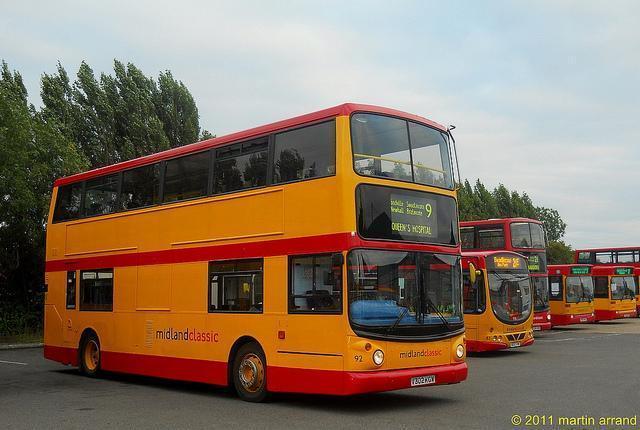How many buses are there?
Give a very brief answer. 6. How many levels are in the front bus?
Give a very brief answer. 2. How many buses are visible?
Give a very brief answer. 6. How many modes of transportation are pictured?
Give a very brief answer. 1. How many buses are here?
Give a very brief answer. 6. 